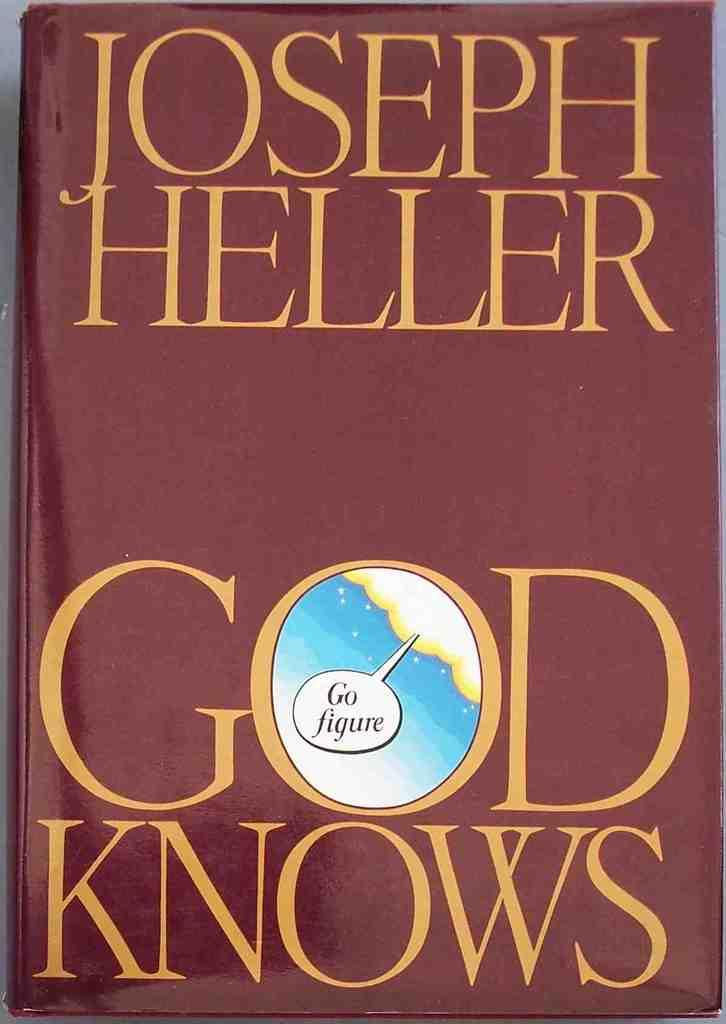What object can be seen in the image? There is a book in the image. What information is provided about the book? The book has the title "Joseph Heller God Knows" written on it. What type of brake is visible on the book in the image? There is no brake present on the book in the image. Is there a net surrounding the book in the image? No, there is no net present in the image. 